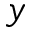Convert formula to latex. <formula><loc_0><loc_0><loc_500><loc_500>y</formula> 